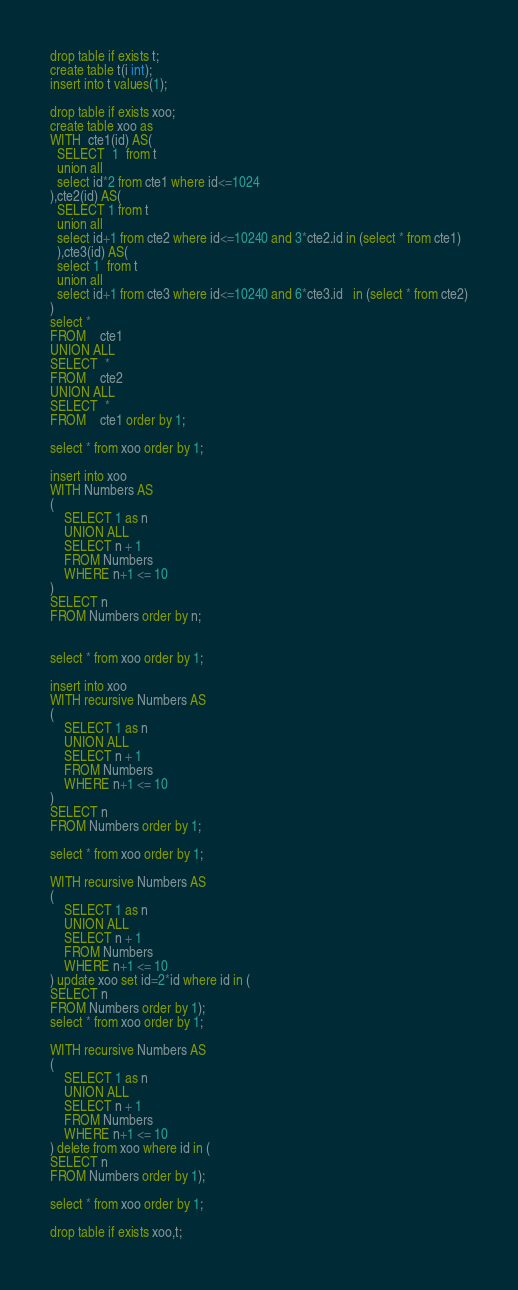Convert code to text. <code><loc_0><loc_0><loc_500><loc_500><_SQL_>
drop table if exists t;
create table t(i int);
insert into t values(1);

drop table if exists xoo;
create table xoo as
WITH  cte1(id) AS(
  SELECT  1  from t
  union all
  select id*2 from cte1 where id<=1024
),cte2(id) AS(
  SELECT 1 from t
  union all
  select id+1 from cte2 where id<=10240 and 3*cte2.id in (select * from cte1)
  ),cte3(id) AS(
  select 1  from t
  union all
  select id+1 from cte3 where id<=10240 and 6*cte3.id   in (select * from cte2)
) 
select *
FROM    cte1
UNION ALL
SELECT  *
FROM    cte2
UNION ALL
SELECT  *
FROM    cte1 order by 1;

select * from xoo order by 1;

insert into xoo
WITH Numbers AS
(
    SELECT 1 as n
    UNION ALL
    SELECT n + 1
    FROM Numbers
    WHERE n+1 <= 10
)
SELECT n
FROM Numbers order by n;


select * from xoo order by 1;

insert into xoo
WITH recursive Numbers AS
(
    SELECT 1 as n
    UNION ALL
    SELECT n + 1
    FROM Numbers
    WHERE n+1 <= 10
)
SELECT n
FROM Numbers order by 1;

select * from xoo order by 1;

WITH recursive Numbers AS
(
    SELECT 1 as n
    UNION ALL
    SELECT n + 1
    FROM Numbers
    WHERE n+1 <= 10
) update xoo set id=2*id where id in (
SELECT n
FROM Numbers order by 1);
select * from xoo order by 1;

WITH recursive Numbers AS
(
    SELECT 1 as n
    UNION ALL
    SELECT n + 1
    FROM Numbers
    WHERE n+1 <= 10
) delete from xoo where id in (
SELECT n
FROM Numbers order by 1);

select * from xoo order by 1;

drop table if exists xoo,t;
</code> 